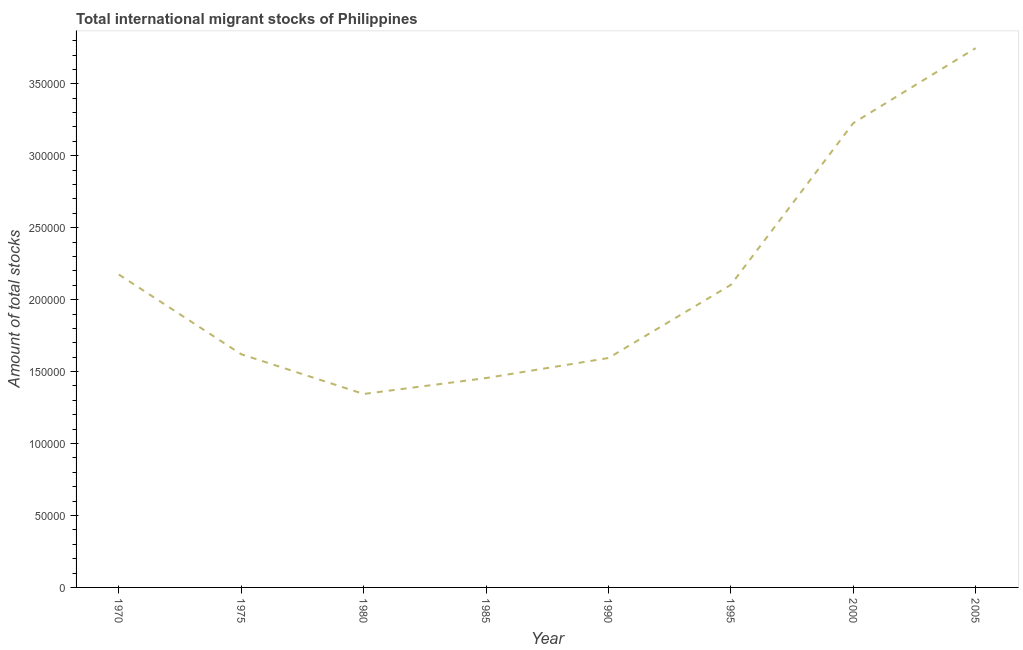What is the total number of international migrant stock in 1975?
Your response must be concise. 1.62e+05. Across all years, what is the maximum total number of international migrant stock?
Make the answer very short. 3.75e+05. Across all years, what is the minimum total number of international migrant stock?
Provide a short and direct response. 1.34e+05. What is the sum of the total number of international migrant stock?
Your answer should be very brief. 1.73e+06. What is the difference between the total number of international migrant stock in 1995 and 2000?
Offer a terse response. -1.12e+05. What is the average total number of international migrant stock per year?
Give a very brief answer. 2.16e+05. What is the median total number of international migrant stock?
Make the answer very short. 1.86e+05. In how many years, is the total number of international migrant stock greater than 50000 ?
Provide a short and direct response. 8. What is the ratio of the total number of international migrant stock in 1975 to that in 2005?
Ensure brevity in your answer.  0.43. Is the difference between the total number of international migrant stock in 1985 and 2005 greater than the difference between any two years?
Provide a succinct answer. No. What is the difference between the highest and the second highest total number of international migrant stock?
Give a very brief answer. 5.21e+04. What is the difference between the highest and the lowest total number of international migrant stock?
Offer a terse response. 2.40e+05. In how many years, is the total number of international migrant stock greater than the average total number of international migrant stock taken over all years?
Ensure brevity in your answer.  3. Are the values on the major ticks of Y-axis written in scientific E-notation?
Your answer should be compact. No. Does the graph contain any zero values?
Give a very brief answer. No. Does the graph contain grids?
Make the answer very short. No. What is the title of the graph?
Your response must be concise. Total international migrant stocks of Philippines. What is the label or title of the Y-axis?
Your answer should be compact. Amount of total stocks. What is the Amount of total stocks in 1970?
Make the answer very short. 2.17e+05. What is the Amount of total stocks of 1975?
Give a very brief answer. 1.62e+05. What is the Amount of total stocks of 1980?
Give a very brief answer. 1.34e+05. What is the Amount of total stocks in 1985?
Provide a short and direct response. 1.46e+05. What is the Amount of total stocks of 1990?
Make the answer very short. 1.59e+05. What is the Amount of total stocks of 1995?
Keep it short and to the point. 2.10e+05. What is the Amount of total stocks of 2000?
Your response must be concise. 3.23e+05. What is the Amount of total stocks in 2005?
Give a very brief answer. 3.75e+05. What is the difference between the Amount of total stocks in 1970 and 1975?
Your response must be concise. 5.54e+04. What is the difference between the Amount of total stocks in 1970 and 1980?
Ensure brevity in your answer.  8.30e+04. What is the difference between the Amount of total stocks in 1970 and 1985?
Give a very brief answer. 7.19e+04. What is the difference between the Amount of total stocks in 1970 and 1990?
Make the answer very short. 5.80e+04. What is the difference between the Amount of total stocks in 1970 and 1995?
Ensure brevity in your answer.  7149. What is the difference between the Amount of total stocks in 1970 and 2000?
Make the answer very short. -1.05e+05. What is the difference between the Amount of total stocks in 1970 and 2005?
Offer a very short reply. -1.57e+05. What is the difference between the Amount of total stocks in 1975 and 1980?
Offer a terse response. 2.76e+04. What is the difference between the Amount of total stocks in 1975 and 1985?
Ensure brevity in your answer.  1.65e+04. What is the difference between the Amount of total stocks in 1975 and 1990?
Your response must be concise. 2615. What is the difference between the Amount of total stocks in 1975 and 1995?
Offer a very short reply. -4.82e+04. What is the difference between the Amount of total stocks in 1975 and 2000?
Provide a short and direct response. -1.61e+05. What is the difference between the Amount of total stocks in 1975 and 2005?
Provide a succinct answer. -2.13e+05. What is the difference between the Amount of total stocks in 1980 and 1985?
Your answer should be compact. -1.11e+04. What is the difference between the Amount of total stocks in 1980 and 1990?
Your answer should be very brief. -2.50e+04. What is the difference between the Amount of total stocks in 1980 and 1995?
Give a very brief answer. -7.58e+04. What is the difference between the Amount of total stocks in 1980 and 2000?
Provide a succinct answer. -1.88e+05. What is the difference between the Amount of total stocks in 1980 and 2005?
Your answer should be compact. -2.40e+05. What is the difference between the Amount of total stocks in 1985 and 1990?
Your response must be concise. -1.39e+04. What is the difference between the Amount of total stocks in 1985 and 1995?
Provide a short and direct response. -6.48e+04. What is the difference between the Amount of total stocks in 1985 and 2000?
Provide a succinct answer. -1.77e+05. What is the difference between the Amount of total stocks in 1985 and 2005?
Your response must be concise. -2.29e+05. What is the difference between the Amount of total stocks in 1990 and 1995?
Give a very brief answer. -5.09e+04. What is the difference between the Amount of total stocks in 1990 and 2000?
Your answer should be compact. -1.63e+05. What is the difference between the Amount of total stocks in 1990 and 2005?
Provide a succinct answer. -2.15e+05. What is the difference between the Amount of total stocks in 1995 and 2000?
Give a very brief answer. -1.12e+05. What is the difference between the Amount of total stocks in 1995 and 2005?
Provide a short and direct response. -1.64e+05. What is the difference between the Amount of total stocks in 2000 and 2005?
Offer a very short reply. -5.21e+04. What is the ratio of the Amount of total stocks in 1970 to that in 1975?
Your answer should be compact. 1.34. What is the ratio of the Amount of total stocks in 1970 to that in 1980?
Keep it short and to the point. 1.62. What is the ratio of the Amount of total stocks in 1970 to that in 1985?
Ensure brevity in your answer.  1.49. What is the ratio of the Amount of total stocks in 1970 to that in 1990?
Your answer should be compact. 1.36. What is the ratio of the Amount of total stocks in 1970 to that in 1995?
Offer a terse response. 1.03. What is the ratio of the Amount of total stocks in 1970 to that in 2000?
Offer a terse response. 0.67. What is the ratio of the Amount of total stocks in 1970 to that in 2005?
Your answer should be very brief. 0.58. What is the ratio of the Amount of total stocks in 1975 to that in 1980?
Ensure brevity in your answer.  1.21. What is the ratio of the Amount of total stocks in 1975 to that in 1985?
Offer a terse response. 1.11. What is the ratio of the Amount of total stocks in 1975 to that in 1995?
Offer a very short reply. 0.77. What is the ratio of the Amount of total stocks in 1975 to that in 2000?
Provide a succinct answer. 0.5. What is the ratio of the Amount of total stocks in 1975 to that in 2005?
Offer a very short reply. 0.43. What is the ratio of the Amount of total stocks in 1980 to that in 1985?
Ensure brevity in your answer.  0.92. What is the ratio of the Amount of total stocks in 1980 to that in 1990?
Ensure brevity in your answer.  0.84. What is the ratio of the Amount of total stocks in 1980 to that in 1995?
Offer a very short reply. 0.64. What is the ratio of the Amount of total stocks in 1980 to that in 2000?
Your answer should be compact. 0.42. What is the ratio of the Amount of total stocks in 1980 to that in 2005?
Give a very brief answer. 0.36. What is the ratio of the Amount of total stocks in 1985 to that in 1990?
Offer a terse response. 0.91. What is the ratio of the Amount of total stocks in 1985 to that in 1995?
Give a very brief answer. 0.69. What is the ratio of the Amount of total stocks in 1985 to that in 2000?
Keep it short and to the point. 0.45. What is the ratio of the Amount of total stocks in 1985 to that in 2005?
Offer a terse response. 0.39. What is the ratio of the Amount of total stocks in 1990 to that in 1995?
Give a very brief answer. 0.76. What is the ratio of the Amount of total stocks in 1990 to that in 2000?
Give a very brief answer. 0.49. What is the ratio of the Amount of total stocks in 1990 to that in 2005?
Make the answer very short. 0.42. What is the ratio of the Amount of total stocks in 1995 to that in 2000?
Offer a terse response. 0.65. What is the ratio of the Amount of total stocks in 1995 to that in 2005?
Your response must be concise. 0.56. What is the ratio of the Amount of total stocks in 2000 to that in 2005?
Your answer should be compact. 0.86. 